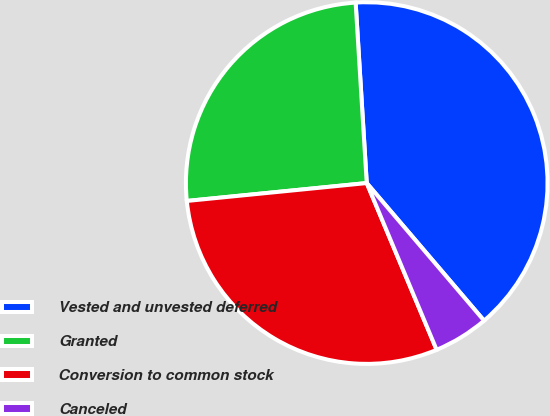<chart> <loc_0><loc_0><loc_500><loc_500><pie_chart><fcel>Vested and unvested deferred<fcel>Granted<fcel>Conversion to common stock<fcel>Canceled<nl><fcel>39.74%<fcel>25.6%<fcel>29.74%<fcel>4.92%<nl></chart> 